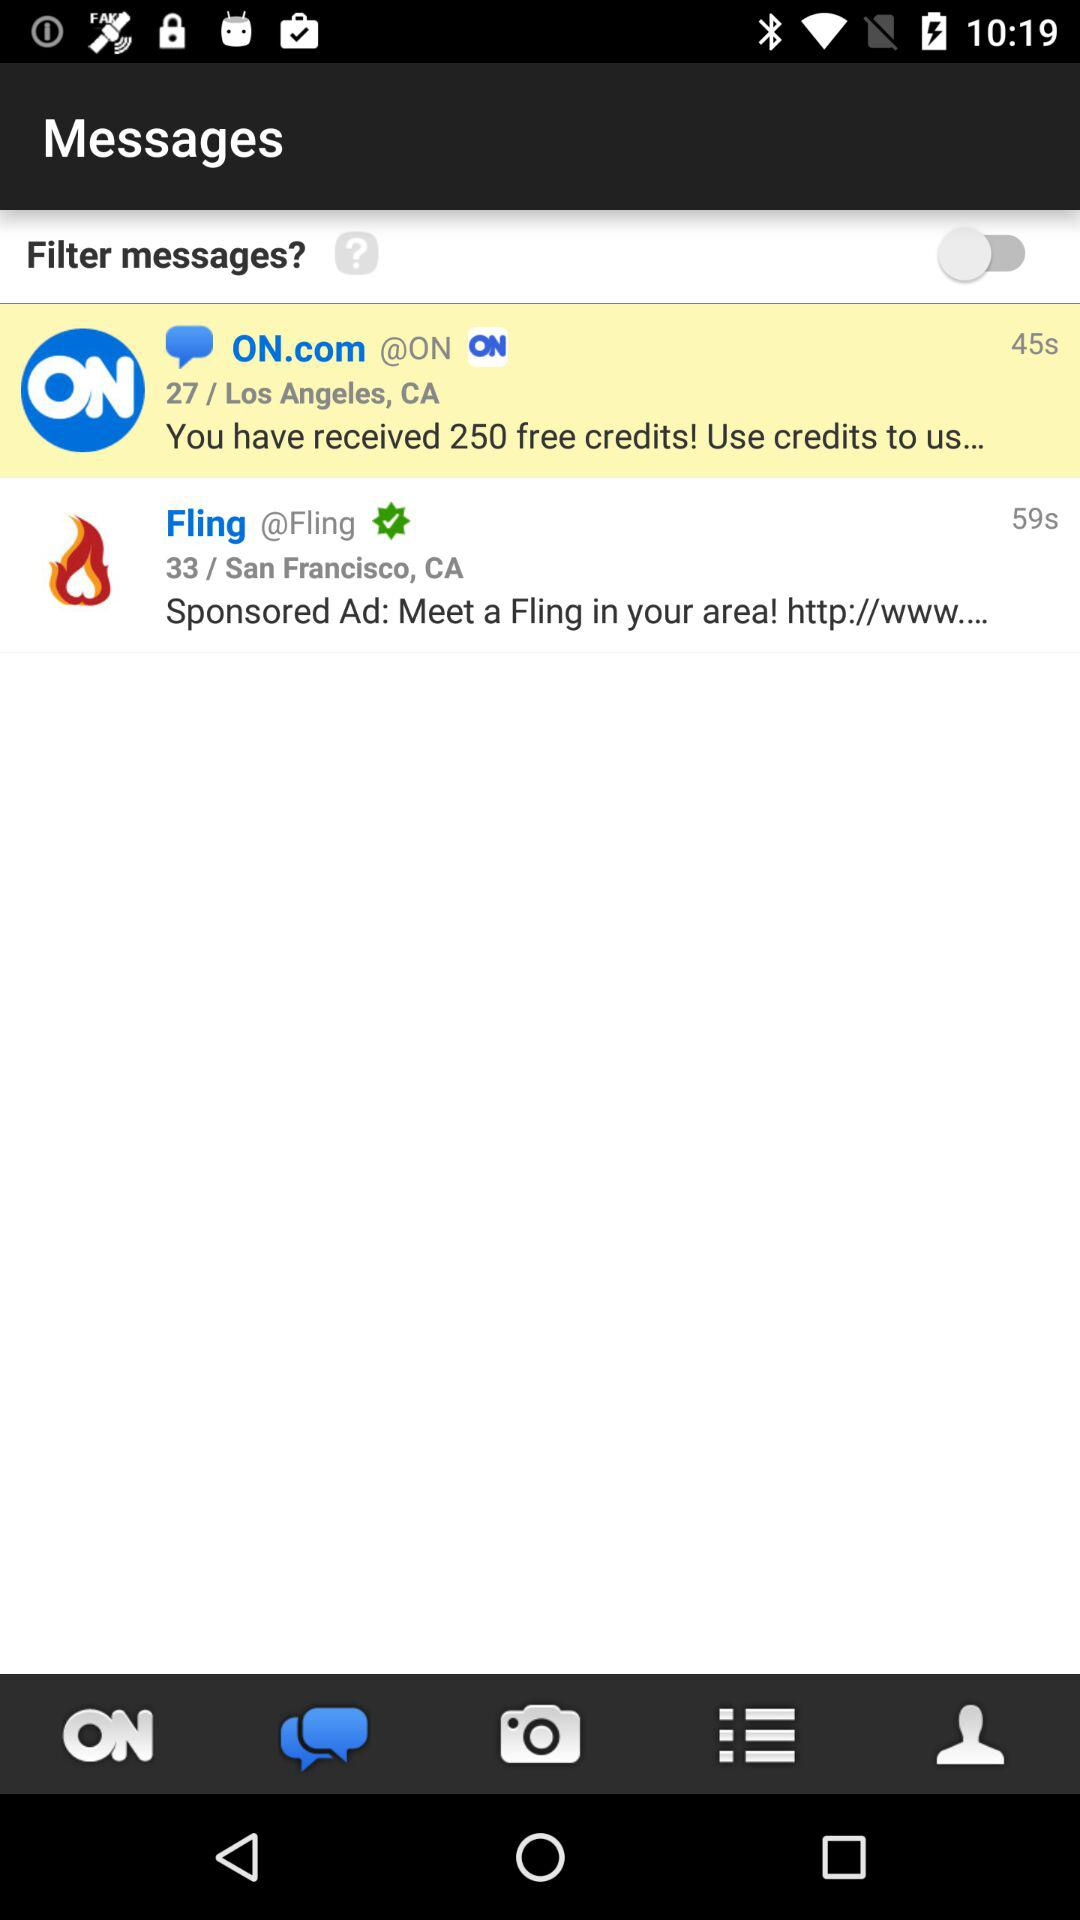How many seconds ago did "Fling" send the message? "Fling" sent the message 59 seconds ago. 